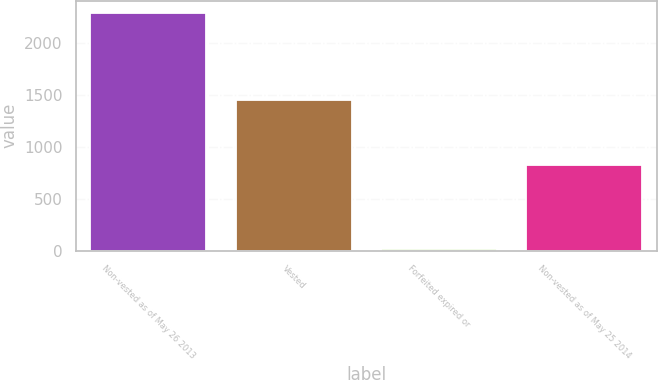<chart> <loc_0><loc_0><loc_500><loc_500><bar_chart><fcel>Non-vested as of May 26 2013<fcel>Vested<fcel>Forfeited expired or<fcel>Non-vested as of May 25 2014<nl><fcel>2287.8<fcel>1445.5<fcel>19.5<fcel>822.8<nl></chart> 